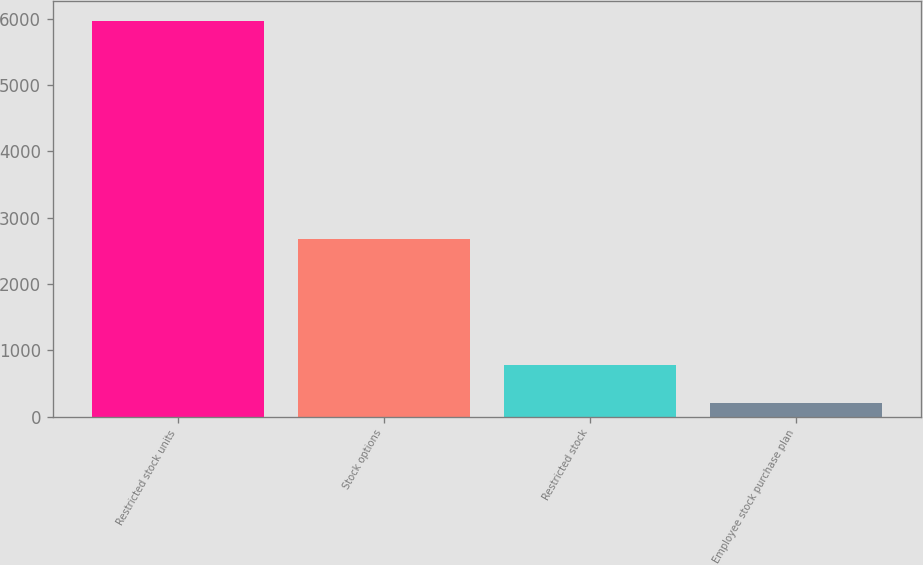Convert chart to OTSL. <chart><loc_0><loc_0><loc_500><loc_500><bar_chart><fcel>Restricted stock units<fcel>Stock options<fcel>Restricted stock<fcel>Employee stock purchase plan<nl><fcel>5970<fcel>2680<fcel>775.2<fcel>198<nl></chart> 